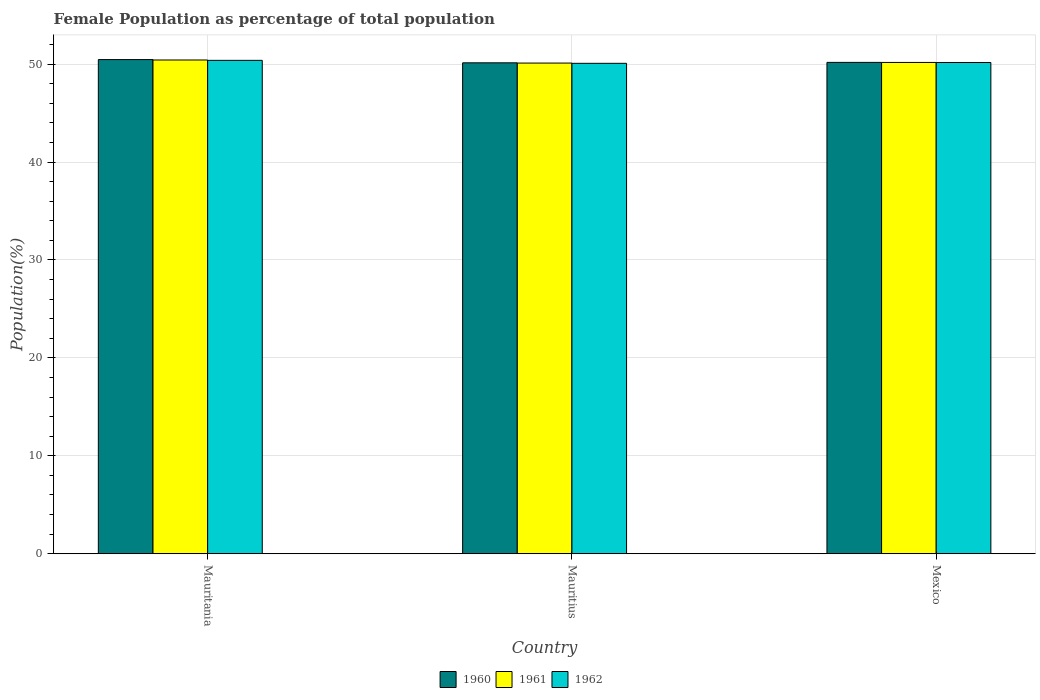How many groups of bars are there?
Provide a succinct answer. 3. Are the number of bars on each tick of the X-axis equal?
Ensure brevity in your answer.  Yes. How many bars are there on the 1st tick from the right?
Your answer should be very brief. 3. In how many cases, is the number of bars for a given country not equal to the number of legend labels?
Keep it short and to the point. 0. What is the female population in in 1960 in Mauritania?
Your response must be concise. 50.47. Across all countries, what is the maximum female population in in 1961?
Your answer should be compact. 50.43. Across all countries, what is the minimum female population in in 1962?
Offer a terse response. 50.09. In which country was the female population in in 1961 maximum?
Provide a short and direct response. Mauritania. In which country was the female population in in 1962 minimum?
Give a very brief answer. Mauritius. What is the total female population in in 1961 in the graph?
Your answer should be very brief. 150.71. What is the difference between the female population in in 1962 in Mauritania and that in Mauritius?
Your answer should be very brief. 0.3. What is the difference between the female population in in 1961 in Mauritius and the female population in in 1960 in Mauritania?
Make the answer very short. -0.36. What is the average female population in in 1962 per country?
Offer a terse response. 50.22. What is the difference between the female population in of/in 1960 and female population in of/in 1961 in Mexico?
Ensure brevity in your answer.  0.01. What is the ratio of the female population in in 1962 in Mauritania to that in Mauritius?
Offer a very short reply. 1.01. What is the difference between the highest and the second highest female population in in 1961?
Offer a terse response. 0.25. What is the difference between the highest and the lowest female population in in 1960?
Keep it short and to the point. 0.33. In how many countries, is the female population in in 1961 greater than the average female population in in 1961 taken over all countries?
Give a very brief answer. 1. Is it the case that in every country, the sum of the female population in in 1960 and female population in in 1961 is greater than the female population in in 1962?
Make the answer very short. Yes. How many bars are there?
Your response must be concise. 9. Are all the bars in the graph horizontal?
Provide a short and direct response. No. What is the difference between two consecutive major ticks on the Y-axis?
Offer a terse response. 10. Where does the legend appear in the graph?
Keep it short and to the point. Bottom center. What is the title of the graph?
Offer a very short reply. Female Population as percentage of total population. Does "1979" appear as one of the legend labels in the graph?
Your response must be concise. No. What is the label or title of the X-axis?
Provide a short and direct response. Country. What is the label or title of the Y-axis?
Provide a short and direct response. Population(%). What is the Population(%) of 1960 in Mauritania?
Provide a short and direct response. 50.47. What is the Population(%) of 1961 in Mauritania?
Ensure brevity in your answer.  50.43. What is the Population(%) of 1962 in Mauritania?
Your answer should be compact. 50.39. What is the Population(%) of 1960 in Mauritius?
Your response must be concise. 50.14. What is the Population(%) of 1961 in Mauritius?
Your response must be concise. 50.11. What is the Population(%) in 1962 in Mauritius?
Provide a short and direct response. 50.09. What is the Population(%) in 1960 in Mexico?
Provide a short and direct response. 50.18. What is the Population(%) in 1961 in Mexico?
Offer a terse response. 50.18. What is the Population(%) of 1962 in Mexico?
Your response must be concise. 50.17. Across all countries, what is the maximum Population(%) of 1960?
Make the answer very short. 50.47. Across all countries, what is the maximum Population(%) of 1961?
Your response must be concise. 50.43. Across all countries, what is the maximum Population(%) of 1962?
Your answer should be compact. 50.39. Across all countries, what is the minimum Population(%) of 1960?
Keep it short and to the point. 50.14. Across all countries, what is the minimum Population(%) in 1961?
Provide a succinct answer. 50.11. Across all countries, what is the minimum Population(%) of 1962?
Your answer should be very brief. 50.09. What is the total Population(%) of 1960 in the graph?
Offer a very short reply. 150.79. What is the total Population(%) of 1961 in the graph?
Ensure brevity in your answer.  150.71. What is the total Population(%) of 1962 in the graph?
Your answer should be very brief. 150.65. What is the difference between the Population(%) in 1960 in Mauritania and that in Mauritius?
Your answer should be compact. 0.33. What is the difference between the Population(%) of 1961 in Mauritania and that in Mauritius?
Provide a short and direct response. 0.31. What is the difference between the Population(%) of 1962 in Mauritania and that in Mauritius?
Offer a terse response. 0.3. What is the difference between the Population(%) in 1960 in Mauritania and that in Mexico?
Give a very brief answer. 0.29. What is the difference between the Population(%) of 1961 in Mauritania and that in Mexico?
Keep it short and to the point. 0.25. What is the difference between the Population(%) in 1962 in Mauritania and that in Mexico?
Ensure brevity in your answer.  0.22. What is the difference between the Population(%) in 1960 in Mauritius and that in Mexico?
Ensure brevity in your answer.  -0.04. What is the difference between the Population(%) of 1961 in Mauritius and that in Mexico?
Make the answer very short. -0.06. What is the difference between the Population(%) in 1962 in Mauritius and that in Mexico?
Offer a very short reply. -0.08. What is the difference between the Population(%) in 1960 in Mauritania and the Population(%) in 1961 in Mauritius?
Offer a very short reply. 0.36. What is the difference between the Population(%) in 1960 in Mauritania and the Population(%) in 1962 in Mauritius?
Make the answer very short. 0.38. What is the difference between the Population(%) of 1961 in Mauritania and the Population(%) of 1962 in Mauritius?
Offer a very short reply. 0.34. What is the difference between the Population(%) of 1960 in Mauritania and the Population(%) of 1961 in Mexico?
Give a very brief answer. 0.29. What is the difference between the Population(%) of 1960 in Mauritania and the Population(%) of 1962 in Mexico?
Keep it short and to the point. 0.3. What is the difference between the Population(%) of 1961 in Mauritania and the Population(%) of 1962 in Mexico?
Ensure brevity in your answer.  0.26. What is the difference between the Population(%) of 1960 in Mauritius and the Population(%) of 1961 in Mexico?
Offer a very short reply. -0.04. What is the difference between the Population(%) in 1960 in Mauritius and the Population(%) in 1962 in Mexico?
Your response must be concise. -0.03. What is the difference between the Population(%) of 1961 in Mauritius and the Population(%) of 1962 in Mexico?
Your answer should be compact. -0.06. What is the average Population(%) in 1960 per country?
Give a very brief answer. 50.26. What is the average Population(%) of 1961 per country?
Provide a succinct answer. 50.24. What is the average Population(%) in 1962 per country?
Offer a very short reply. 50.22. What is the difference between the Population(%) of 1960 and Population(%) of 1961 in Mauritania?
Ensure brevity in your answer.  0.04. What is the difference between the Population(%) in 1960 and Population(%) in 1962 in Mauritania?
Your answer should be very brief. 0.08. What is the difference between the Population(%) in 1961 and Population(%) in 1962 in Mauritania?
Your answer should be very brief. 0.04. What is the difference between the Population(%) in 1960 and Population(%) in 1961 in Mauritius?
Offer a terse response. 0.03. What is the difference between the Population(%) of 1960 and Population(%) of 1962 in Mauritius?
Your answer should be very brief. 0.05. What is the difference between the Population(%) of 1961 and Population(%) of 1962 in Mauritius?
Ensure brevity in your answer.  0.03. What is the difference between the Population(%) of 1960 and Population(%) of 1961 in Mexico?
Your answer should be very brief. 0.01. What is the difference between the Population(%) of 1960 and Population(%) of 1962 in Mexico?
Provide a short and direct response. 0.01. What is the difference between the Population(%) of 1961 and Population(%) of 1962 in Mexico?
Ensure brevity in your answer.  0.01. What is the ratio of the Population(%) in 1960 in Mauritania to that in Mauritius?
Keep it short and to the point. 1.01. What is the ratio of the Population(%) in 1961 in Mauritania to that in Mexico?
Provide a succinct answer. 1. What is the ratio of the Population(%) of 1960 in Mauritius to that in Mexico?
Give a very brief answer. 1. What is the ratio of the Population(%) of 1962 in Mauritius to that in Mexico?
Keep it short and to the point. 1. What is the difference between the highest and the second highest Population(%) in 1960?
Give a very brief answer. 0.29. What is the difference between the highest and the second highest Population(%) in 1961?
Provide a succinct answer. 0.25. What is the difference between the highest and the second highest Population(%) of 1962?
Provide a short and direct response. 0.22. What is the difference between the highest and the lowest Population(%) in 1960?
Your answer should be very brief. 0.33. What is the difference between the highest and the lowest Population(%) in 1961?
Provide a short and direct response. 0.31. What is the difference between the highest and the lowest Population(%) in 1962?
Give a very brief answer. 0.3. 